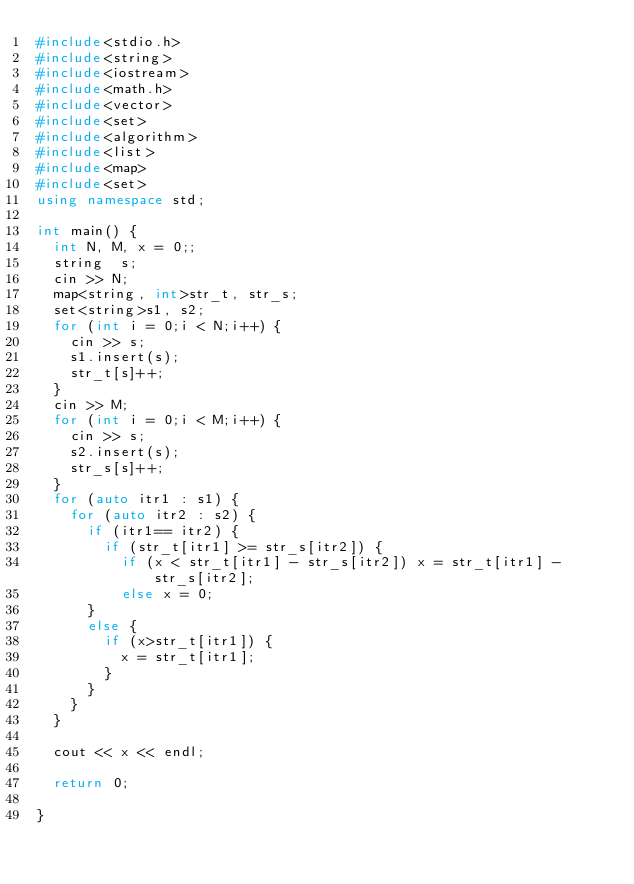Convert code to text. <code><loc_0><loc_0><loc_500><loc_500><_C++_>#include<stdio.h>
#include<string>
#include<iostream>
#include<math.h>
#include<vector>
#include<set>
#include<algorithm>
#include<list>
#include<map>
#include<set>
using namespace std;

int main() {
	int N, M, x = 0;;
	string  s;
	cin >> N;
	map<string, int>str_t, str_s;
	set<string>s1, s2;
	for (int i = 0;i < N;i++) {
		cin >> s;
		s1.insert(s);
		str_t[s]++;
	}
	cin >> M;
	for (int i = 0;i < M;i++) {
		cin >> s;
		s2.insert(s);
		str_s[s]++;
	}
	for (auto itr1 : s1) {
		for (auto itr2 : s2) {
			if (itr1== itr2) {
				if (str_t[itr1] >= str_s[itr2]) {
					if (x < str_t[itr1] - str_s[itr2]) x = str_t[itr1] - str_s[itr2];
					else x = 0;
			}
			else {
				if (x>str_t[itr1]) {
					x = str_t[itr1];
				}
			}
		}
	}
	
	cout << x << endl;

	return 0;

}</code> 